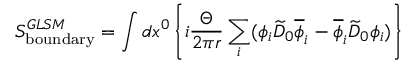<formula> <loc_0><loc_0><loc_500><loc_500>S _ { b o u n d a r y } ^ { G L S M } = \int d x ^ { 0 } \left \{ i { \frac { \Theta } { 2 \pi r } } \sum _ { i } ( \phi _ { i } \widetilde { D } _ { 0 } \overline { \phi } _ { i } - \overline { \phi } _ { i } \widetilde { D } _ { 0 } \phi _ { i } ) \right \}</formula> 